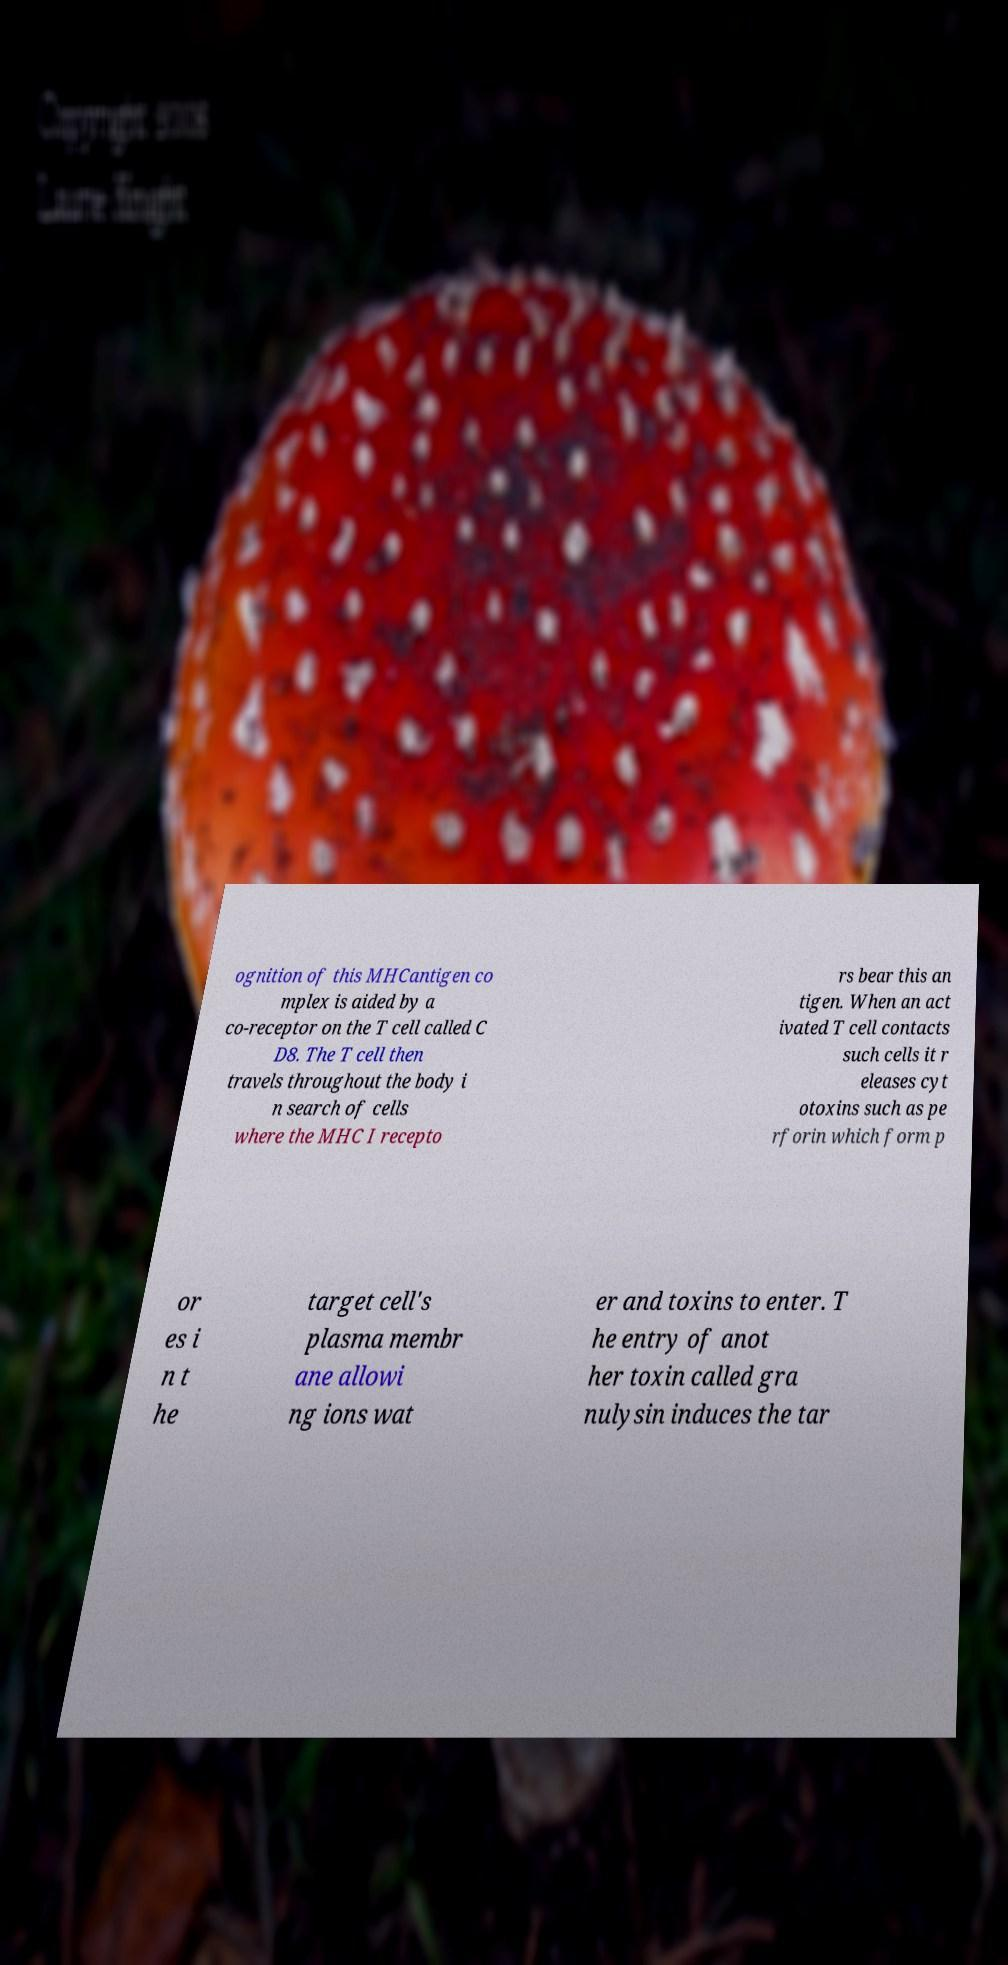Please identify and transcribe the text found in this image. ognition of this MHCantigen co mplex is aided by a co-receptor on the T cell called C D8. The T cell then travels throughout the body i n search of cells where the MHC I recepto rs bear this an tigen. When an act ivated T cell contacts such cells it r eleases cyt otoxins such as pe rforin which form p or es i n t he target cell's plasma membr ane allowi ng ions wat er and toxins to enter. T he entry of anot her toxin called gra nulysin induces the tar 